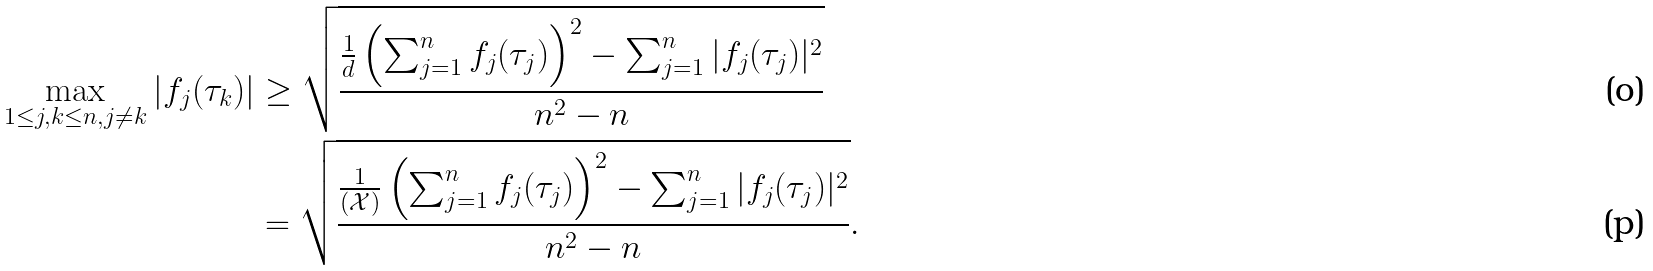<formula> <loc_0><loc_0><loc_500><loc_500>\max _ { 1 \leq j , k \leq n , j \neq k } | f _ { j } ( \tau _ { k } ) | & \geq \sqrt { \frac { \frac { 1 } { d } \left ( \sum _ { j = 1 } ^ { n } f _ { j } ( \tau _ { j } ) \right ) ^ { 2 } - \sum _ { j = 1 } ^ { n } | f _ { j } ( \tau _ { j } ) | ^ { 2 } } { n ^ { 2 } - n } } \\ & = \sqrt { \frac { \frac { 1 } { ( \mathcal { X } ) } \left ( \sum _ { j = 1 } ^ { n } f _ { j } ( \tau _ { j } ) \right ) ^ { 2 } - \sum _ { j = 1 } ^ { n } | f _ { j } ( \tau _ { j } ) | ^ { 2 } } { n ^ { 2 } - n } } .</formula> 